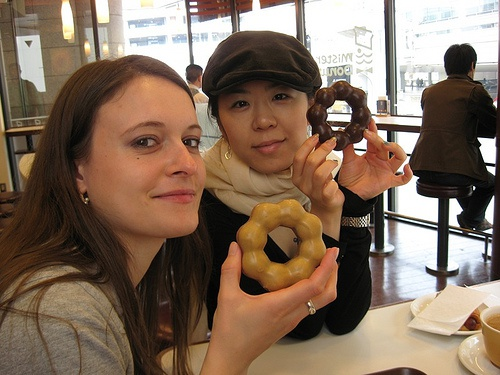Describe the objects in this image and their specific colors. I can see people in gray, black, and maroon tones, people in gray, black, brown, and maroon tones, people in gray, black, maroon, and white tones, dining table in gray and tan tones, and donut in gray, olive, maroon, and black tones in this image. 